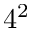<formula> <loc_0><loc_0><loc_500><loc_500>4 ^ { 2 }</formula> 